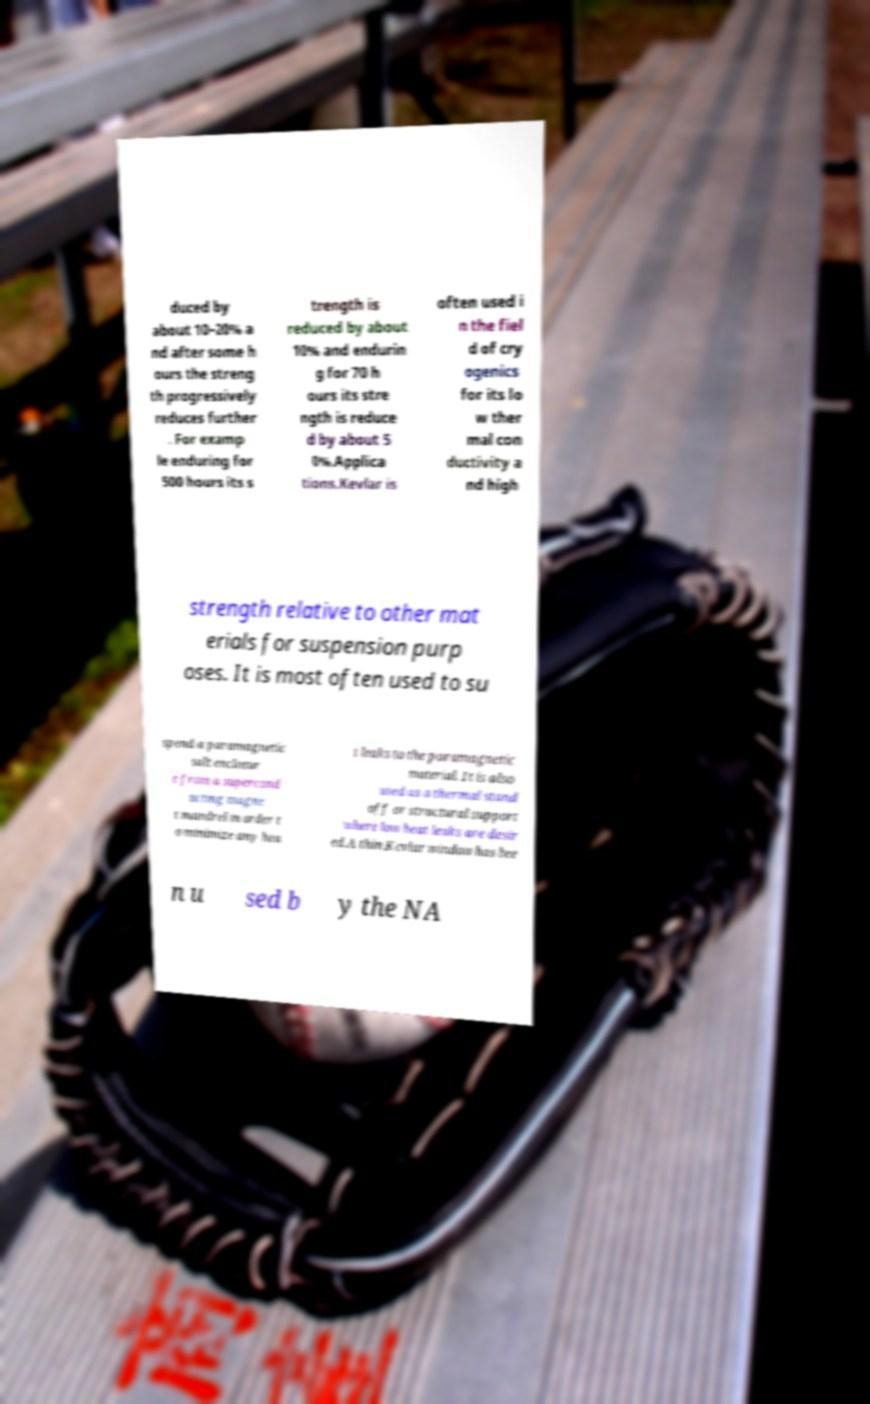What messages or text are displayed in this image? I need them in a readable, typed format. duced by about 10–20% a nd after some h ours the streng th progressively reduces further . For examp le enduring for 500 hours its s trength is reduced by about 10% and endurin g for 70 h ours its stre ngth is reduce d by about 5 0%.Applica tions.Kevlar is often used i n the fiel d of cry ogenics for its lo w ther mal con ductivity a nd high strength relative to other mat erials for suspension purp oses. It is most often used to su spend a paramagnetic salt enclosur e from a supercond ucting magne t mandrel in order t o minimize any hea t leaks to the paramagnetic material. It is also used as a thermal stand off or structural support where low heat leaks are desir ed.A thin Kevlar window has bee n u sed b y the NA 